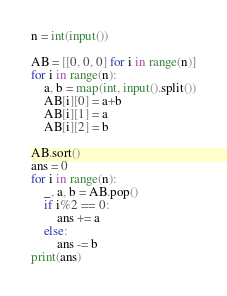Convert code to text. <code><loc_0><loc_0><loc_500><loc_500><_Python_>n = int(input())

AB = [[0, 0, 0] for i in range(n)]
for i in range(n):
    a, b = map(int, input().split())
    AB[i][0] = a+b
    AB[i][1] = a
    AB[i][2] = b

AB.sort()
ans = 0
for i in range(n):
    _, a, b = AB.pop()
    if i%2 == 0:
        ans += a
    else:
        ans -= b
print(ans)</code> 